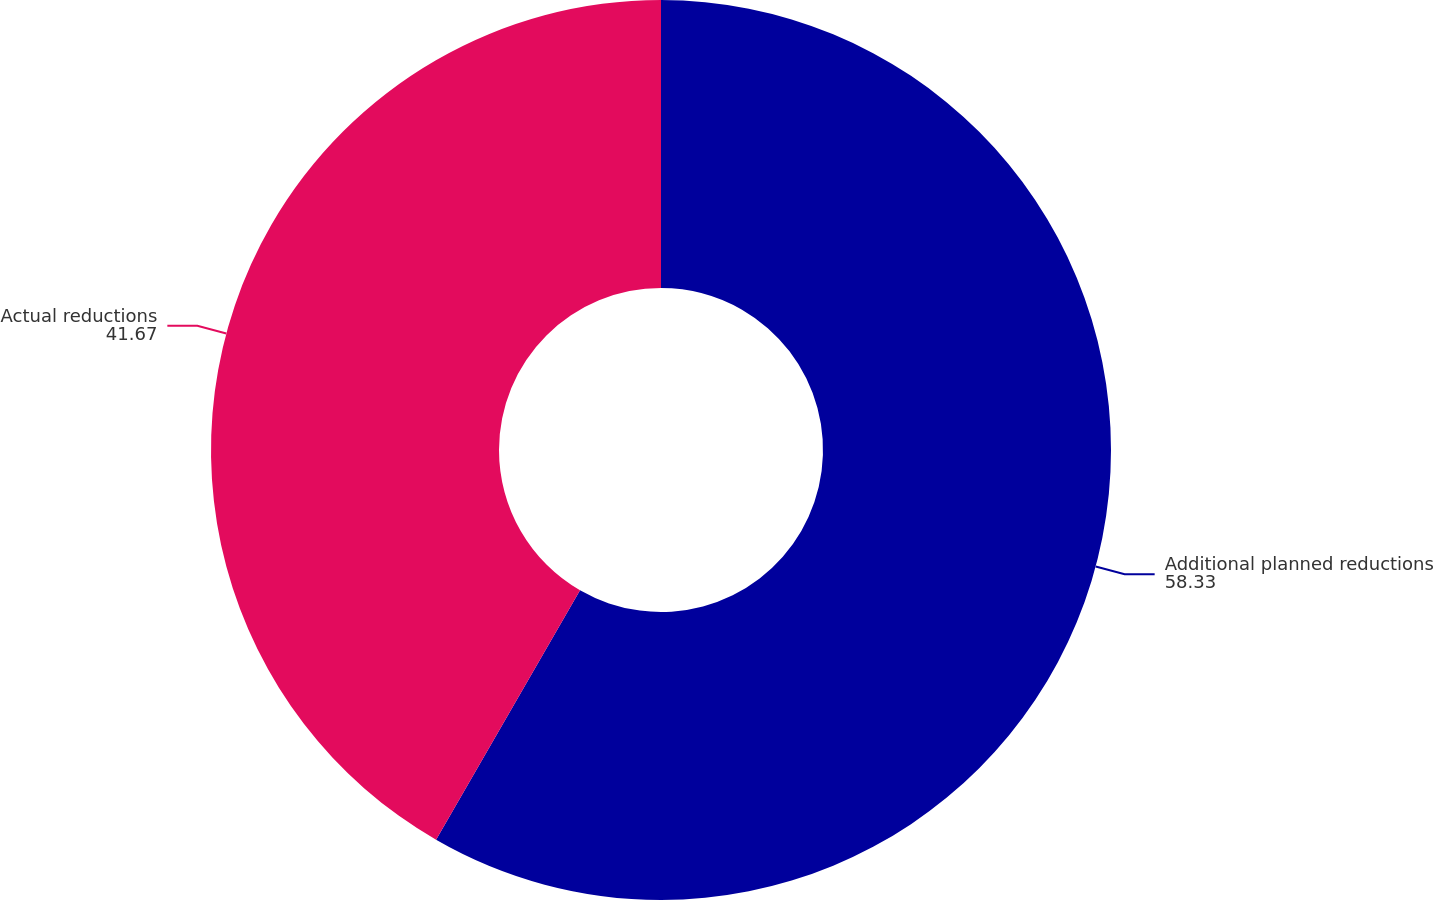<chart> <loc_0><loc_0><loc_500><loc_500><pie_chart><fcel>Additional planned reductions<fcel>Actual reductions<nl><fcel>58.33%<fcel>41.67%<nl></chart> 